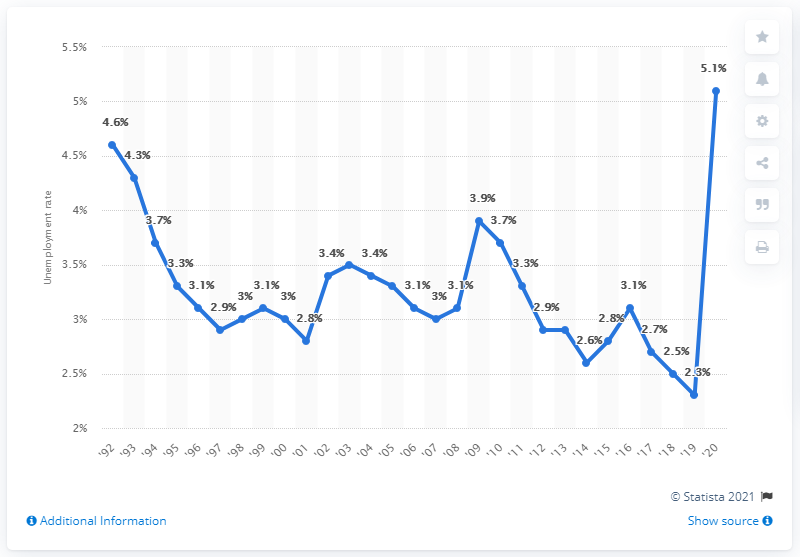Point out several critical features in this image. The previous unemployment rate in North Dakota was 2.3%. The unemployment rate in North Dakota in 2020 was 5.1%. 